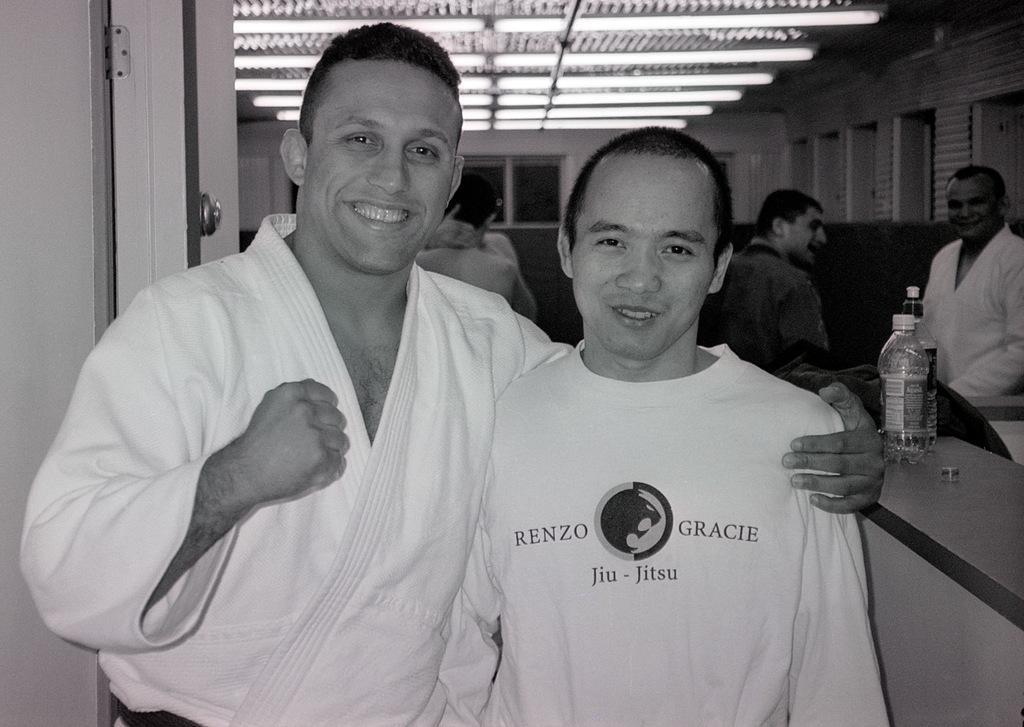Could you give a brief overview of what you see in this image? A boy is posing to camera along with a karate player. There are some other people behind these. 